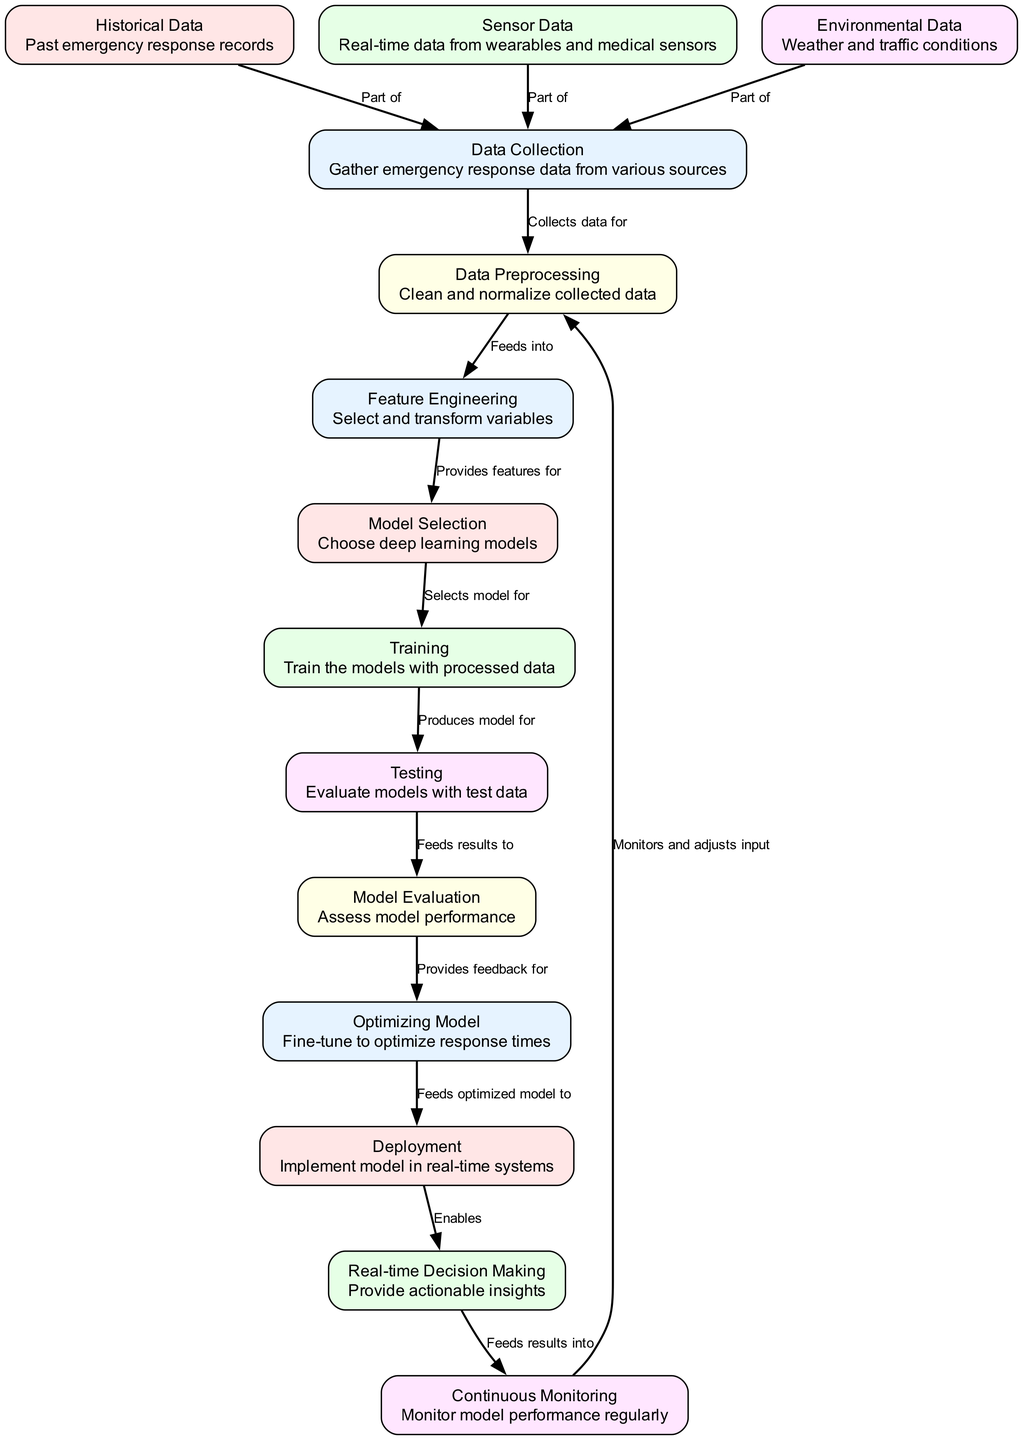What's the total number of nodes in the diagram? The diagram includes a list of various nodes representing different stages in the emergency response optimization process. There are 13 nodes: Data Collection, Historical Data, Sensor Data, Environmental Data, Data Preprocessing, Feature Engineering, Model Selection, Training, Testing, Model Evaluation, Optimizing Model, Deployment, and Real-time Decision Making.
Answer: 13 What is the label of the node that collects data? The node that collects data is labeled "Data Collection." It is the starting point of the process, as indicated in the diagram.
Answer: Data Collection Which nodes provide data to the Data Preprocessing node? The Data Preprocessing node is fed by three specific nodes: Historical Data, Sensor Data, and Environmental Data, as shown by their connections in the diagram.
Answer: Historical Data, Sensor Data, Environmental Data How many edges are there connecting nodes in the diagram? The diagram has various edges connecting the nodes. By counting all the connections listed in the edges section, there are a total of 12 edges that illustrate the relationships between different stages of the process.
Answer: 12 Which node is the final step before Real-time Decision Making? The final step before Real-time Decision Making is the Deployment node. According to the flow of the diagram, the Optimizing Model feeds into Deployment, which then leads to Real-time Decision Making.
Answer: Deployment What type of data is part of the Data Collection node? The Data Collection node encompasses three types of data: Historical Data, Sensor Data, and Environmental Data. Each of these contributes to gathering comprehensive response data.
Answer: Historical Data, Sensor Data, Environmental Data What does the Model Evaluation node provide feedback for? The Model Evaluation node provides feedback for the Optimizing Model. This feedback is essential for refining and enhancing the model's performance based on evaluation results.
Answer: Optimizing Model Which node monitors model performance regularly? Continuous Monitoring is the node that monitors model performance regularly throughout the process depicted in the diagram. It ensures that the model remains effective over time.
Answer: Continuous Monitoring What is the main purpose of Feature Engineering in the diagram? Feature Engineering’s main purpose in the diagram is to select and transform variables, which makes it a crucial step that provides features for subsequent model selection.
Answer: Select and transform variables 